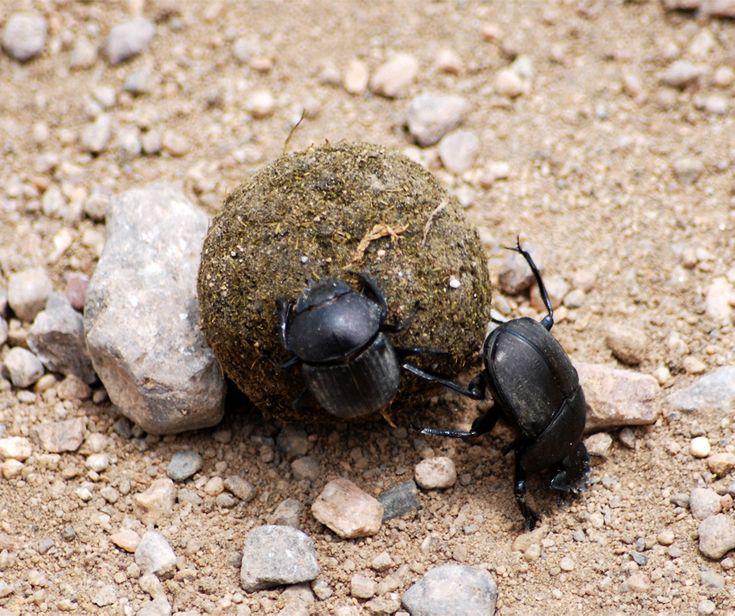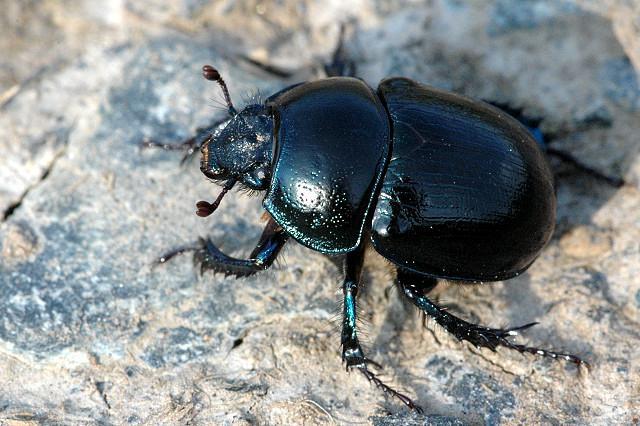The first image is the image on the left, the second image is the image on the right. Examine the images to the left and right. Is the description "An image includes two beetles, with at least one beetle in contact with a round dungball." accurate? Answer yes or no. Yes. The first image is the image on the left, the second image is the image on the right. Examine the images to the left and right. Is the description "There are two beetles near a clod of dirt in one of the images." accurate? Answer yes or no. Yes. 